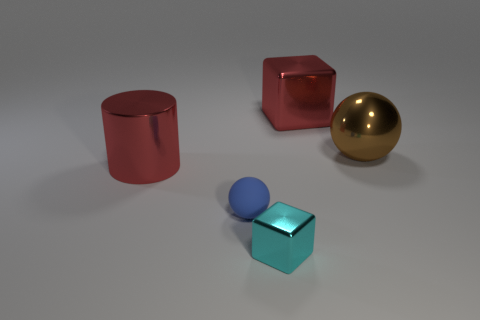There is a brown thing that is the same size as the red metal cylinder; what shape is it?
Ensure brevity in your answer.  Sphere. How many other things are there of the same color as the large sphere?
Provide a short and direct response. 0. The metal object that is both behind the small cyan shiny cube and in front of the big shiny sphere has what shape?
Provide a succinct answer. Cylinder. Is there a metal sphere in front of the big red metal thing that is in front of the big red metallic object behind the brown metal sphere?
Provide a short and direct response. No. How many other things are there of the same material as the tiny ball?
Give a very brief answer. 0. What number of yellow metallic cylinders are there?
Your response must be concise. 0. What number of things are brown metallic things or big red things that are right of the big metal cylinder?
Your answer should be very brief. 2. Is there anything else that has the same shape as the cyan shiny object?
Ensure brevity in your answer.  Yes. There is a metallic thing that is to the left of the cyan object; is its size the same as the small cyan cube?
Offer a terse response. No. How many rubber things are either big yellow objects or tiny blue things?
Offer a very short reply. 1. 